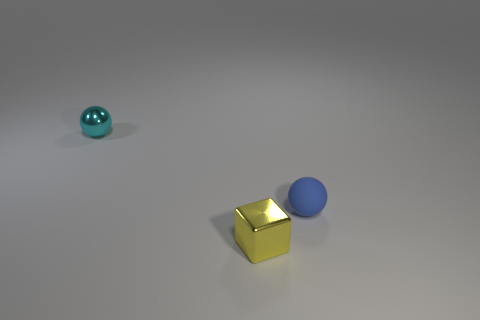Are there fewer blue spheres than brown rubber things?
Your answer should be compact. No. There is a tiny shiny thing to the left of the yellow shiny cube; is it the same color as the rubber ball?
Keep it short and to the point. No. Are there fewer cyan metal balls in front of the matte ball than tiny gray rubber objects?
Provide a short and direct response. No. What shape is the small cyan thing that is made of the same material as the yellow block?
Your answer should be very brief. Sphere. Is the material of the yellow block the same as the cyan object?
Offer a very short reply. Yes. Is the number of blue spheres behind the blue thing less than the number of blue matte balls on the left side of the cyan object?
Offer a terse response. No. How many small balls are behind the small shiny object that is behind the tiny blue ball that is in front of the cyan object?
Ensure brevity in your answer.  0. What color is the rubber ball that is the same size as the cyan metal sphere?
Ensure brevity in your answer.  Blue. Is there another cyan matte thing that has the same shape as the tiny cyan thing?
Provide a short and direct response. No. There is a small metallic thing that is in front of the metal thing behind the blue thing; is there a ball that is to the right of it?
Make the answer very short. Yes. 